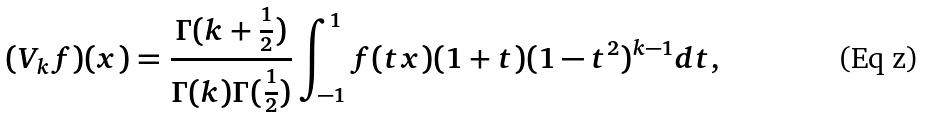Convert formula to latex. <formula><loc_0><loc_0><loc_500><loc_500>( V _ { k } f ) ( x ) = \frac { \Gamma ( k + \frac { 1 } { 2 } ) } { \Gamma ( k ) \Gamma ( \frac { 1 } { 2 } ) } \int _ { - 1 } ^ { 1 } f ( t x ) ( 1 + t ) ( 1 - t ^ { 2 } ) ^ { k - 1 } d t ,</formula> 